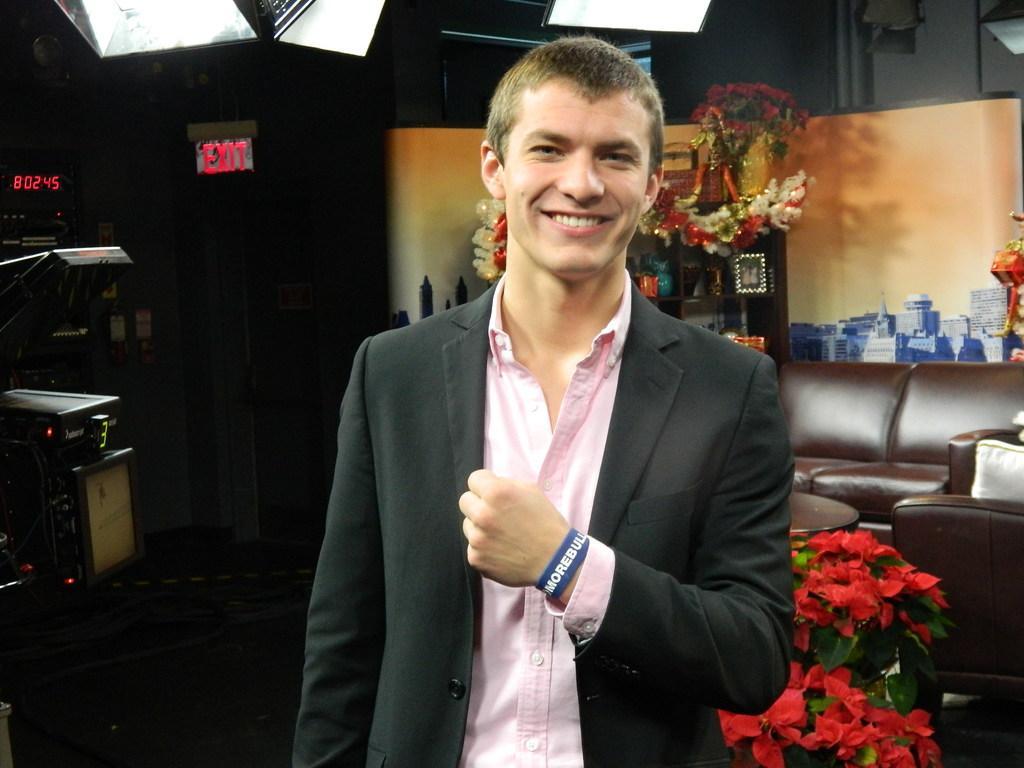Could you give a brief overview of what you see in this image? In this picture there is a man who is wearing blazer shirt and band who standing near to the table. On the table we can see many red roses. In the background we can see couch, plants, photo frames, cotton boxes and other objects. At the top we can see focus lights. On the left there is a camera. 